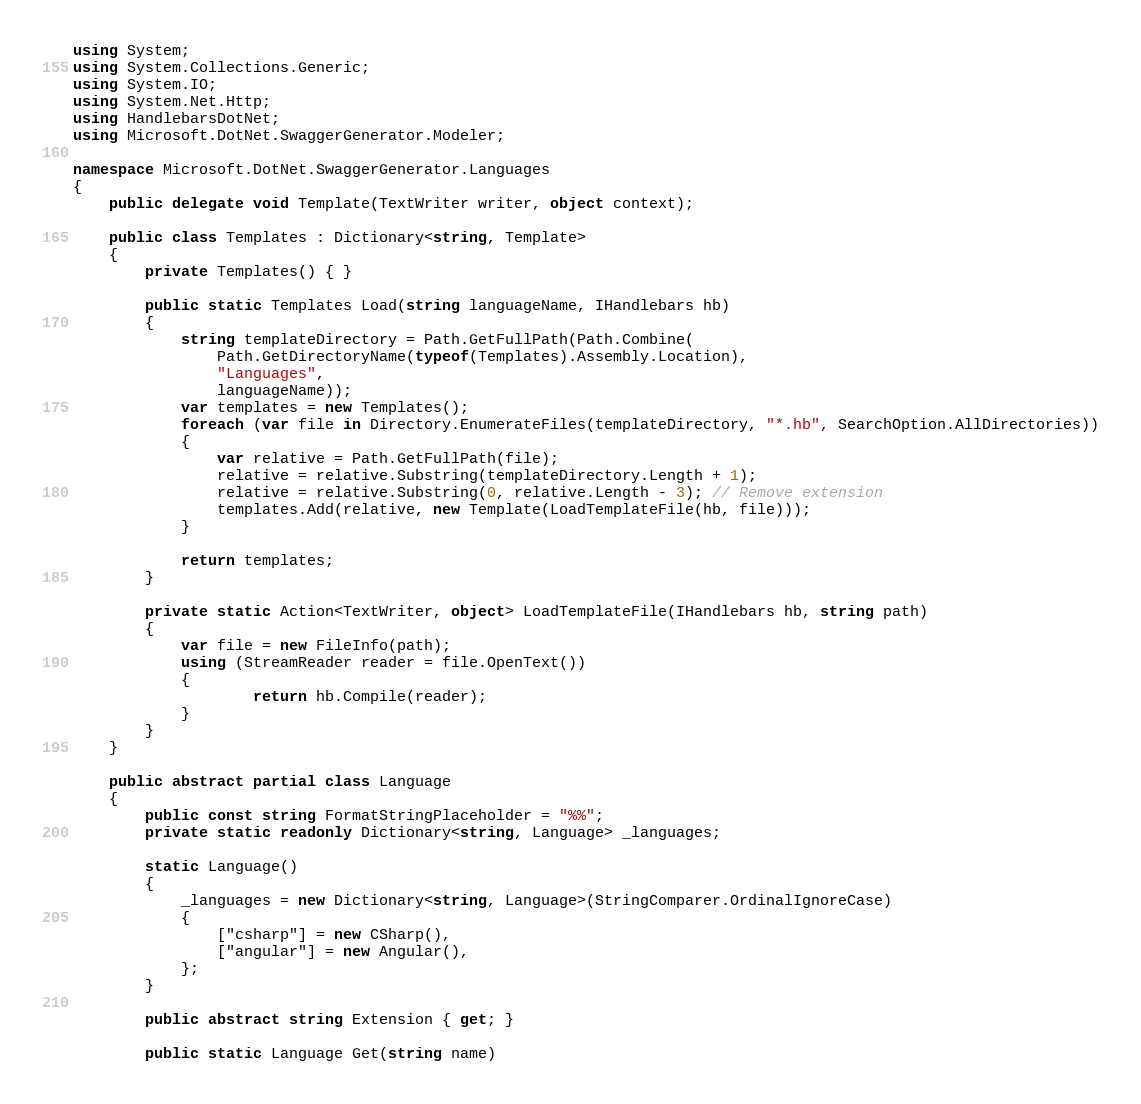Convert code to text. <code><loc_0><loc_0><loc_500><loc_500><_C#_>using System;
using System.Collections.Generic;
using System.IO;
using System.Net.Http;
using HandlebarsDotNet;
using Microsoft.DotNet.SwaggerGenerator.Modeler;

namespace Microsoft.DotNet.SwaggerGenerator.Languages
{
    public delegate void Template(TextWriter writer, object context);

    public class Templates : Dictionary<string, Template>
    {
        private Templates() { }

        public static Templates Load(string languageName, IHandlebars hb)
        {
            string templateDirectory = Path.GetFullPath(Path.Combine(
                Path.GetDirectoryName(typeof(Templates).Assembly.Location),
                "Languages",
                languageName));
            var templates = new Templates();
            foreach (var file in Directory.EnumerateFiles(templateDirectory, "*.hb", SearchOption.AllDirectories))
            {
                var relative = Path.GetFullPath(file);
                relative = relative.Substring(templateDirectory.Length + 1);
                relative = relative.Substring(0, relative.Length - 3); // Remove extension
                templates.Add(relative, new Template(LoadTemplateFile(hb, file)));
            }

            return templates;
        }

        private static Action<TextWriter, object> LoadTemplateFile(IHandlebars hb, string path)
        {
            var file = new FileInfo(path);
            using (StreamReader reader = file.OpenText())
            {
                    return hb.Compile(reader);
            }
        }
    }

    public abstract partial class Language
    {
        public const string FormatStringPlaceholder = "%%";
        private static readonly Dictionary<string, Language> _languages;

        static Language()
        {
            _languages = new Dictionary<string, Language>(StringComparer.OrdinalIgnoreCase)
            {
                ["csharp"] = new CSharp(),
                ["angular"] = new Angular(),
            };
        }

        public abstract string Extension { get; }

        public static Language Get(string name)</code> 